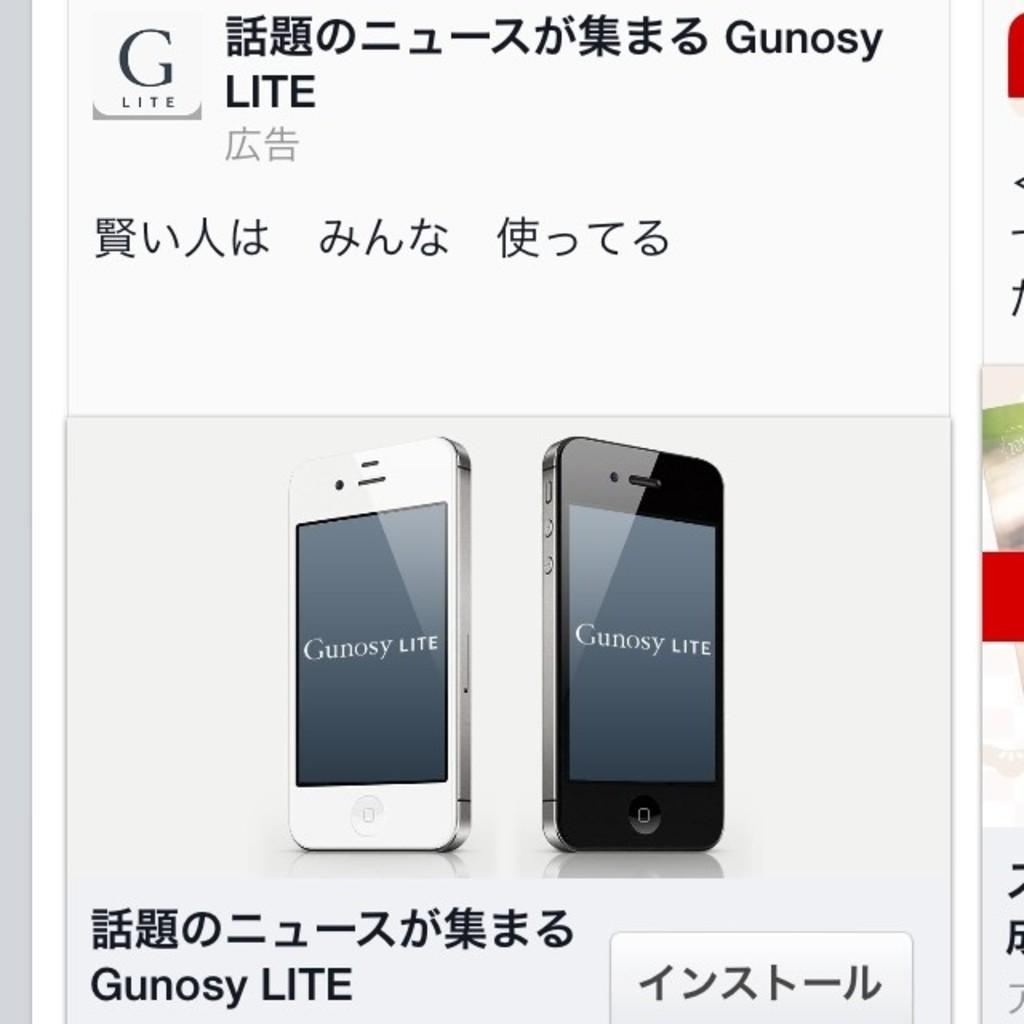Provide a one-sentence caption for the provided image. Two cell phones in an advertisement display the text Gunosy LITE. 